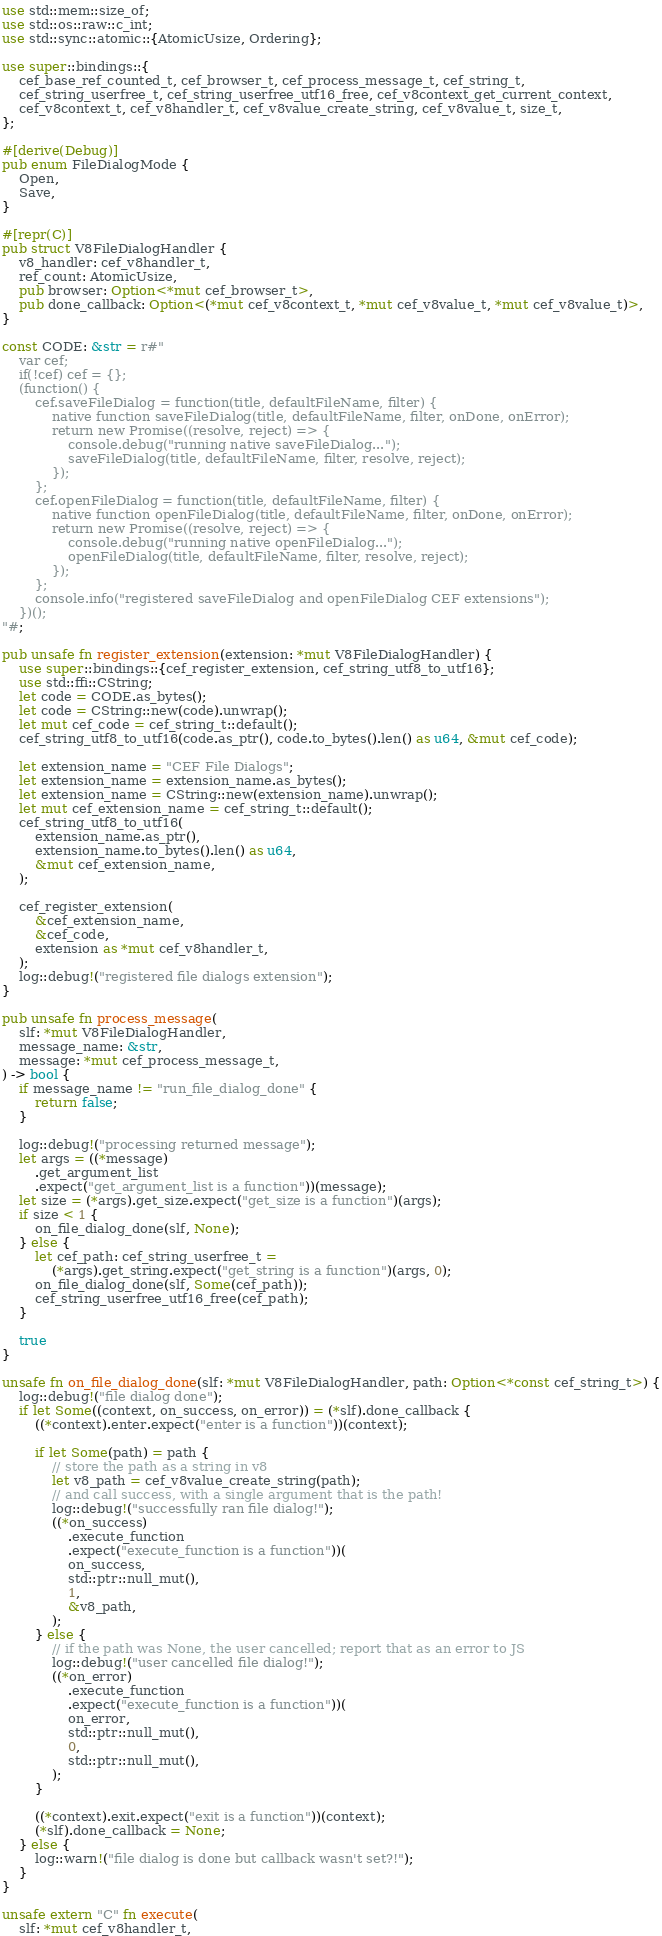<code> <loc_0><loc_0><loc_500><loc_500><_Rust_>use std::mem::size_of;
use std::os::raw::c_int;
use std::sync::atomic::{AtomicUsize, Ordering};

use super::bindings::{
    cef_base_ref_counted_t, cef_browser_t, cef_process_message_t, cef_string_t,
    cef_string_userfree_t, cef_string_userfree_utf16_free, cef_v8context_get_current_context,
    cef_v8context_t, cef_v8handler_t, cef_v8value_create_string, cef_v8value_t, size_t,
};

#[derive(Debug)]
pub enum FileDialogMode {
    Open,
    Save,
}

#[repr(C)]
pub struct V8FileDialogHandler {
    v8_handler: cef_v8handler_t,
    ref_count: AtomicUsize,
    pub browser: Option<*mut cef_browser_t>,
    pub done_callback: Option<(*mut cef_v8context_t, *mut cef_v8value_t, *mut cef_v8value_t)>,
}

const CODE: &str = r#"
    var cef;
    if(!cef) cef = {};
    (function() {
        cef.saveFileDialog = function(title, defaultFileName, filter) {
            native function saveFileDialog(title, defaultFileName, filter, onDone, onError);
            return new Promise((resolve, reject) => {
                console.debug("running native saveFileDialog...");
                saveFileDialog(title, defaultFileName, filter, resolve, reject);
            });
        };
        cef.openFileDialog = function(title, defaultFileName, filter) {
            native function openFileDialog(title, defaultFileName, filter, onDone, onError);
            return new Promise((resolve, reject) => {
                console.debug("running native openFileDialog...");
                openFileDialog(title, defaultFileName, filter, resolve, reject);
            });
        };
        console.info("registered saveFileDialog and openFileDialog CEF extensions");
    })();
"#;

pub unsafe fn register_extension(extension: *mut V8FileDialogHandler) {
    use super::bindings::{cef_register_extension, cef_string_utf8_to_utf16};
    use std::ffi::CString;
    let code = CODE.as_bytes();
    let code = CString::new(code).unwrap();
    let mut cef_code = cef_string_t::default();
    cef_string_utf8_to_utf16(code.as_ptr(), code.to_bytes().len() as u64, &mut cef_code);

    let extension_name = "CEF File Dialogs";
    let extension_name = extension_name.as_bytes();
    let extension_name = CString::new(extension_name).unwrap();
    let mut cef_extension_name = cef_string_t::default();
    cef_string_utf8_to_utf16(
        extension_name.as_ptr(),
        extension_name.to_bytes().len() as u64,
        &mut cef_extension_name,
    );

    cef_register_extension(
        &cef_extension_name,
        &cef_code,
        extension as *mut cef_v8handler_t,
    );
    log::debug!("registered file dialogs extension");
}

pub unsafe fn process_message(
    slf: *mut V8FileDialogHandler,
    message_name: &str,
    message: *mut cef_process_message_t,
) -> bool {
    if message_name != "run_file_dialog_done" {
        return false;
    }

    log::debug!("processing returned message");
    let args = ((*message)
        .get_argument_list
        .expect("get_argument_list is a function"))(message);
    let size = (*args).get_size.expect("get_size is a function")(args);
    if size < 1 {
        on_file_dialog_done(slf, None);
    } else {
        let cef_path: cef_string_userfree_t =
            (*args).get_string.expect("get_string is a function")(args, 0);
        on_file_dialog_done(slf, Some(cef_path));
        cef_string_userfree_utf16_free(cef_path);
    }

    true
}

unsafe fn on_file_dialog_done(slf: *mut V8FileDialogHandler, path: Option<*const cef_string_t>) {
    log::debug!("file dialog done");
    if let Some((context, on_success, on_error)) = (*slf).done_callback {
        ((*context).enter.expect("enter is a function"))(context);

        if let Some(path) = path {
            // store the path as a string in v8
            let v8_path = cef_v8value_create_string(path);
            // and call success, with a single argument that is the path!
            log::debug!("successfully ran file dialog!");
            ((*on_success)
                .execute_function
                .expect("execute_function is a function"))(
                on_success,
                std::ptr::null_mut(),
                1,
                &v8_path,
            );
        } else {
            // if the path was None, the user cancelled; report that as an error to JS
            log::debug!("user cancelled file dialog!");
            ((*on_error)
                .execute_function
                .expect("execute_function is a function"))(
                on_error,
                std::ptr::null_mut(),
                0,
                std::ptr::null_mut(),
            );
        }

        ((*context).exit.expect("exit is a function"))(context);
        (*slf).done_callback = None;
    } else {
        log::warn!("file dialog is done but callback wasn't set?!");
    }
}

unsafe extern "C" fn execute(
    slf: *mut cef_v8handler_t,</code> 